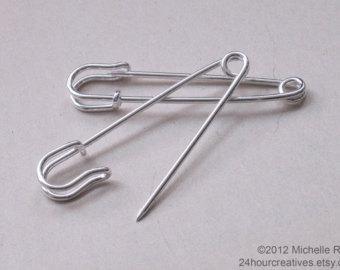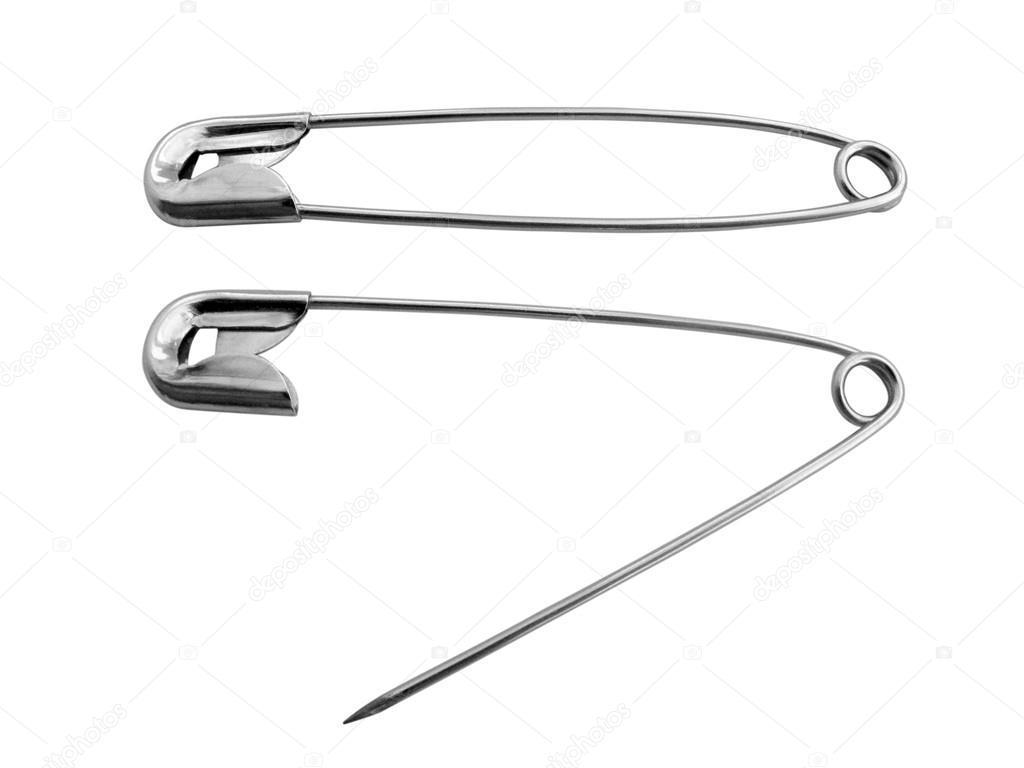The first image is the image on the left, the second image is the image on the right. For the images shown, is this caption "There's at least one open safety pin." true? Answer yes or no. Yes. The first image is the image on the left, the second image is the image on the right. Assess this claim about the two images: "There are four safety pins.". Correct or not? Answer yes or no. Yes. 